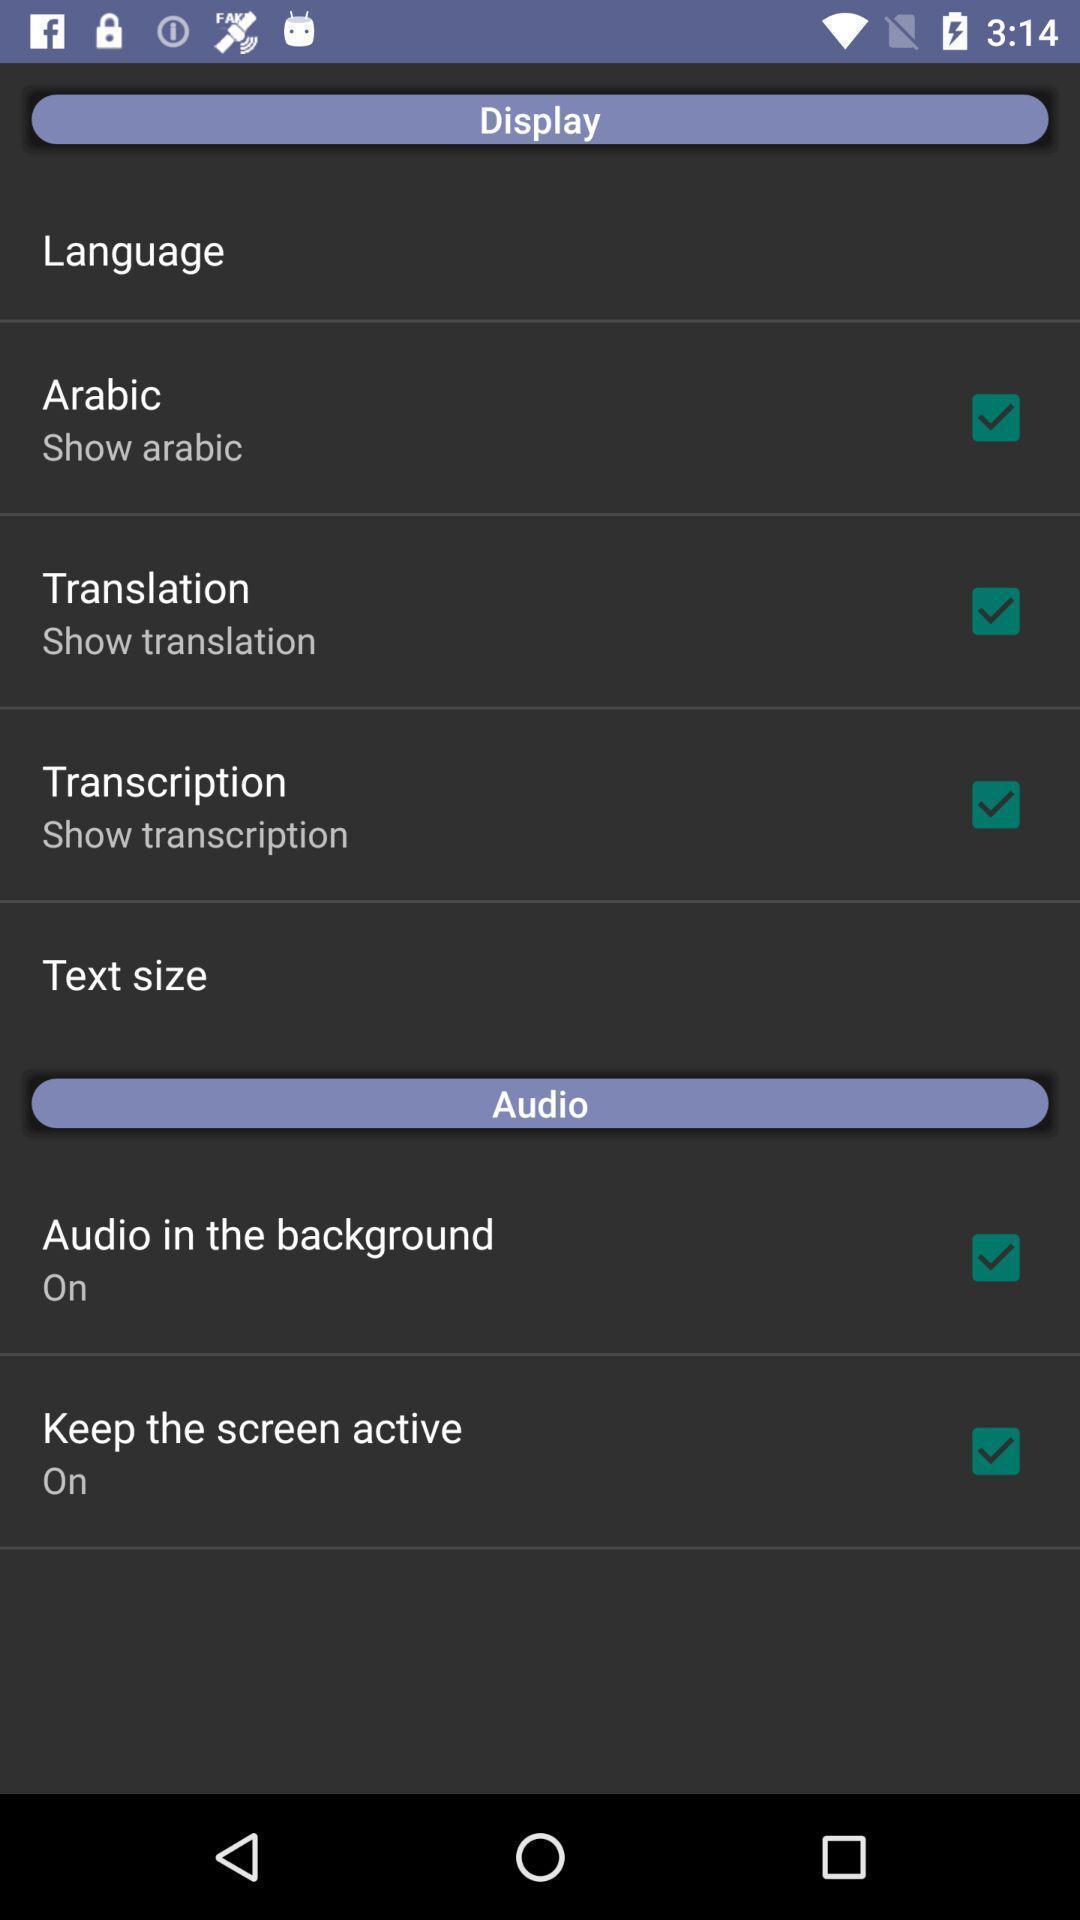What is the overall content of this screenshot? Settings page in a language translation app. 